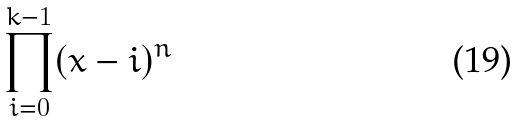<formula> <loc_0><loc_0><loc_500><loc_500>\prod _ { i = 0 } ^ { k - 1 } ( x - i ) ^ { n }</formula> 